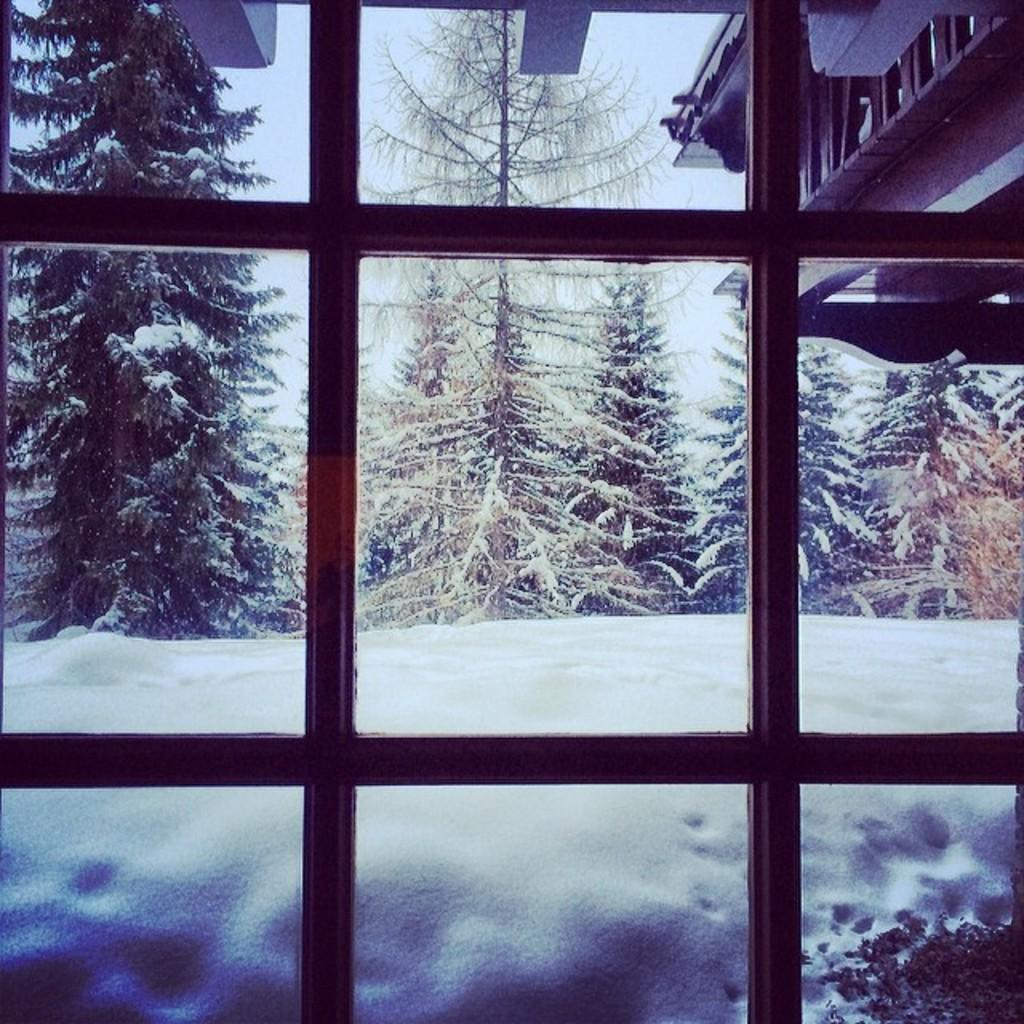What can be seen through the window in the image? Trees are visible behind the window in the image. What type of structure is present in the image? There is a building in the image. What is the weather like in the image? Snow is present in the image, indicating a cold or wintry condition. Can you see an airplane flying in the middle of the image? There is no airplane present in the image. Where is the kettle located in the image? There is no kettle present in the image. 